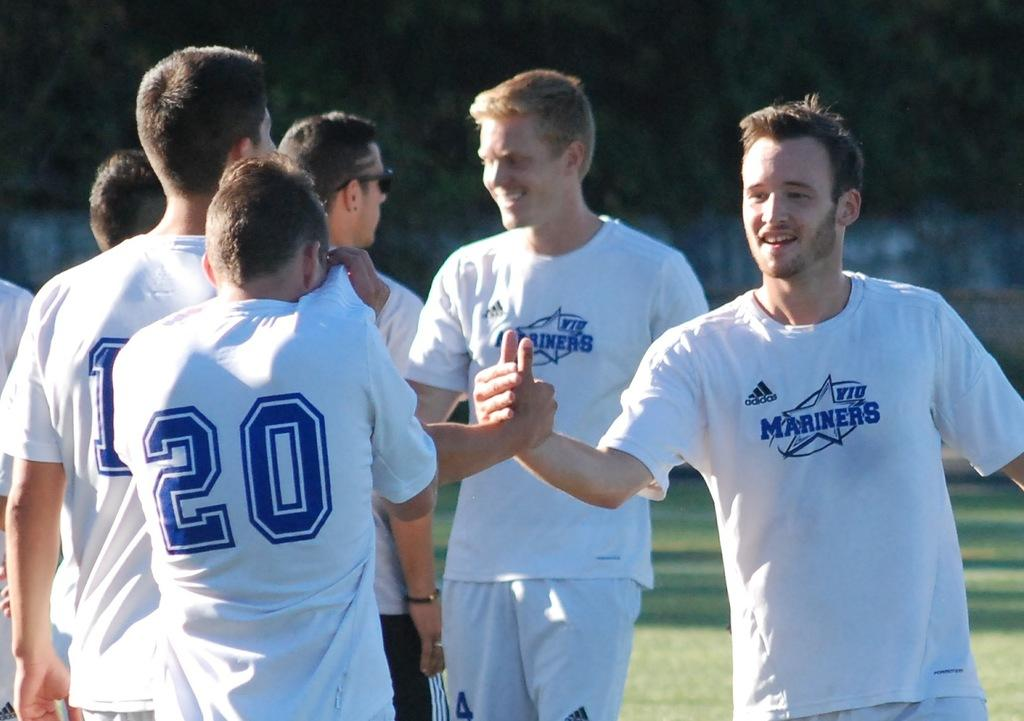<image>
Describe the image concisely. A man with a T-shirt saying Mariners shakes another man's hand. 